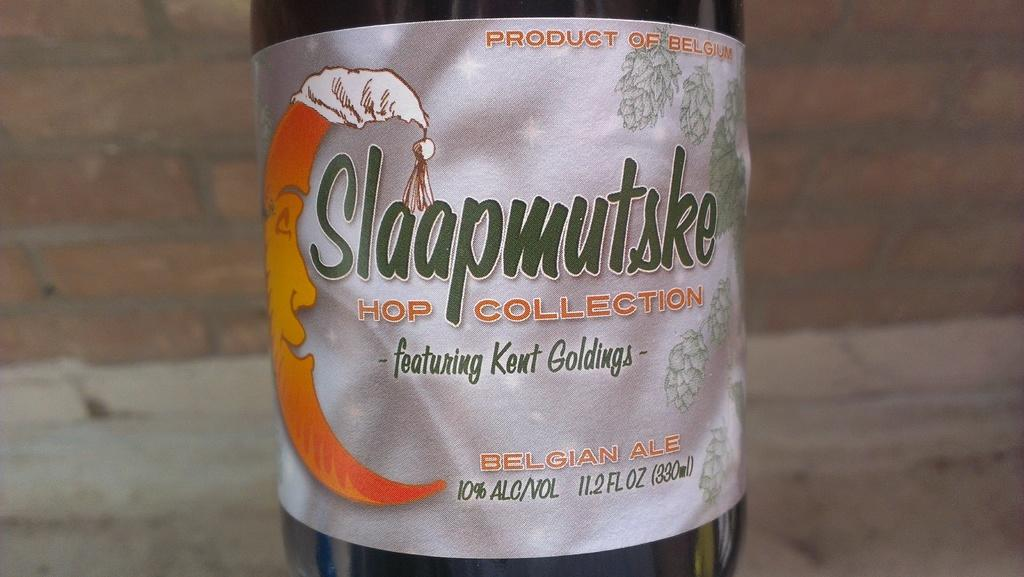Provide a one-sentence caption for the provided image. A bottle of a picture of a moon with on night cap on its head with the brand Slaapmutske as the brand. 